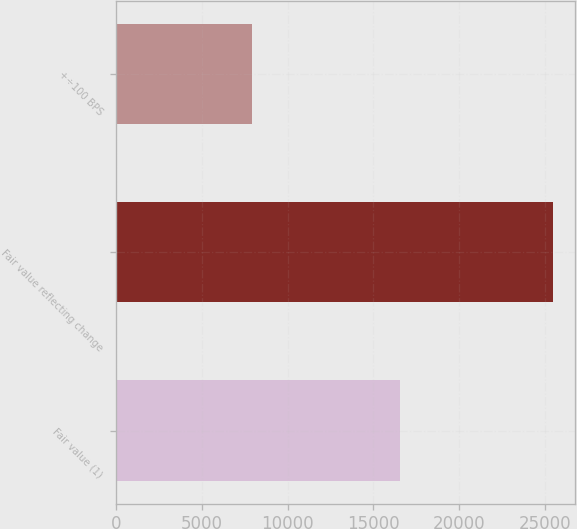<chart> <loc_0><loc_0><loc_500><loc_500><bar_chart><fcel>Fair value (1)<fcel>Fair value reflecting change<fcel>+÷100 BPS<nl><fcel>16550<fcel>25489<fcel>7917<nl></chart> 